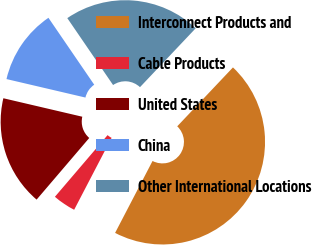Convert chart to OTSL. <chart><loc_0><loc_0><loc_500><loc_500><pie_chart><fcel>Interconnect Products and<fcel>Cable Products<fcel>United States<fcel>China<fcel>Other International Locations<nl><fcel>45.58%<fcel>3.61%<fcel>17.41%<fcel>11.79%<fcel>21.61%<nl></chart> 